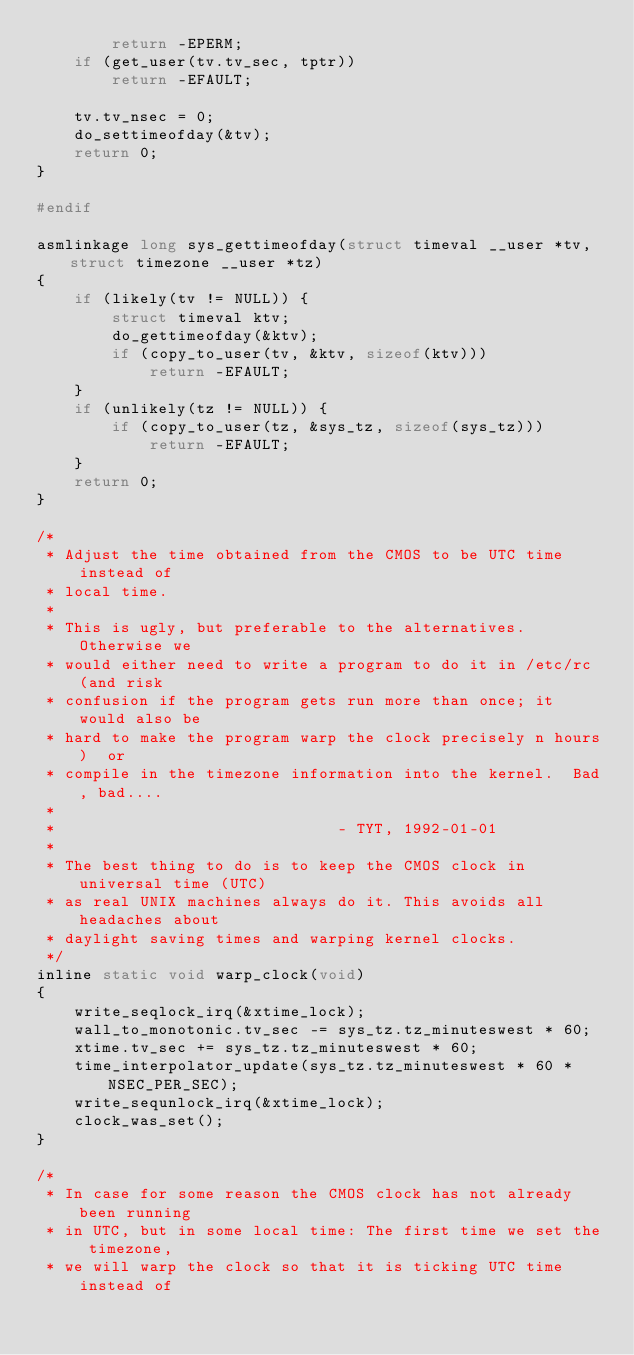<code> <loc_0><loc_0><loc_500><loc_500><_C_>		return -EPERM;
	if (get_user(tv.tv_sec, tptr))
		return -EFAULT;

	tv.tv_nsec = 0;
	do_settimeofday(&tv);
	return 0;
}

#endif

asmlinkage long sys_gettimeofday(struct timeval __user *tv, struct timezone __user *tz)
{
	if (likely(tv != NULL)) {
		struct timeval ktv;
		do_gettimeofday(&ktv);
		if (copy_to_user(tv, &ktv, sizeof(ktv)))
			return -EFAULT;
	}
	if (unlikely(tz != NULL)) {
		if (copy_to_user(tz, &sys_tz, sizeof(sys_tz)))
			return -EFAULT;
	}
	return 0;
}

/*
 * Adjust the time obtained from the CMOS to be UTC time instead of
 * local time.
 * 
 * This is ugly, but preferable to the alternatives.  Otherwise we
 * would either need to write a program to do it in /etc/rc (and risk
 * confusion if the program gets run more than once; it would also be 
 * hard to make the program warp the clock precisely n hours)  or
 * compile in the timezone information into the kernel.  Bad, bad....
 *
 *              				- TYT, 1992-01-01
 *
 * The best thing to do is to keep the CMOS clock in universal time (UTC)
 * as real UNIX machines always do it. This avoids all headaches about
 * daylight saving times and warping kernel clocks.
 */
inline static void warp_clock(void)
{
	write_seqlock_irq(&xtime_lock);
	wall_to_monotonic.tv_sec -= sys_tz.tz_minuteswest * 60;
	xtime.tv_sec += sys_tz.tz_minuteswest * 60;
	time_interpolator_update(sys_tz.tz_minuteswest * 60 * NSEC_PER_SEC);
	write_sequnlock_irq(&xtime_lock);
	clock_was_set();
}

/*
 * In case for some reason the CMOS clock has not already been running
 * in UTC, but in some local time: The first time we set the timezone,
 * we will warp the clock so that it is ticking UTC time instead of</code> 